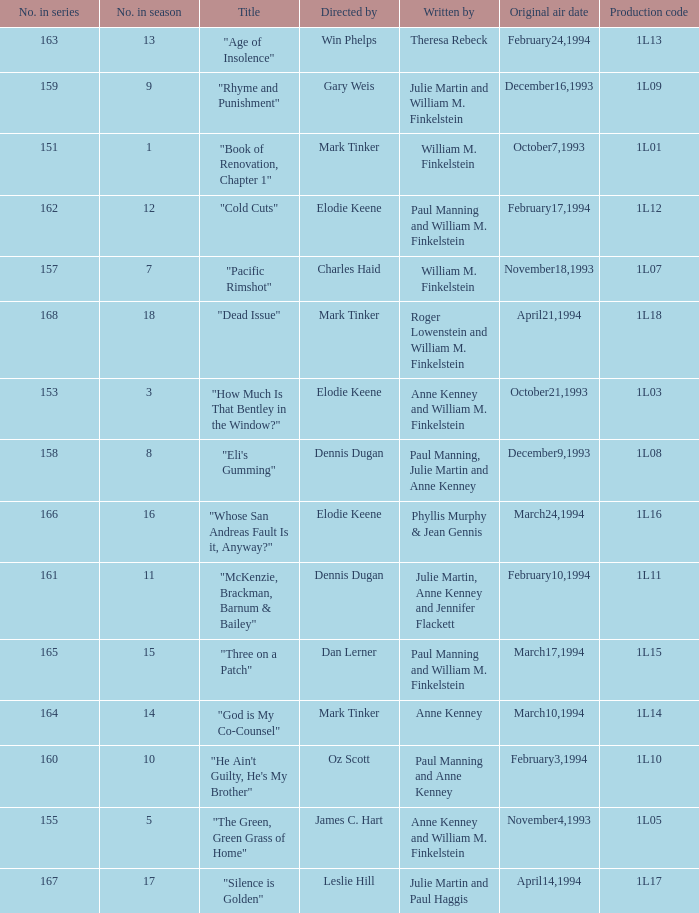Name the production code for theresa rebeck 1L13. 